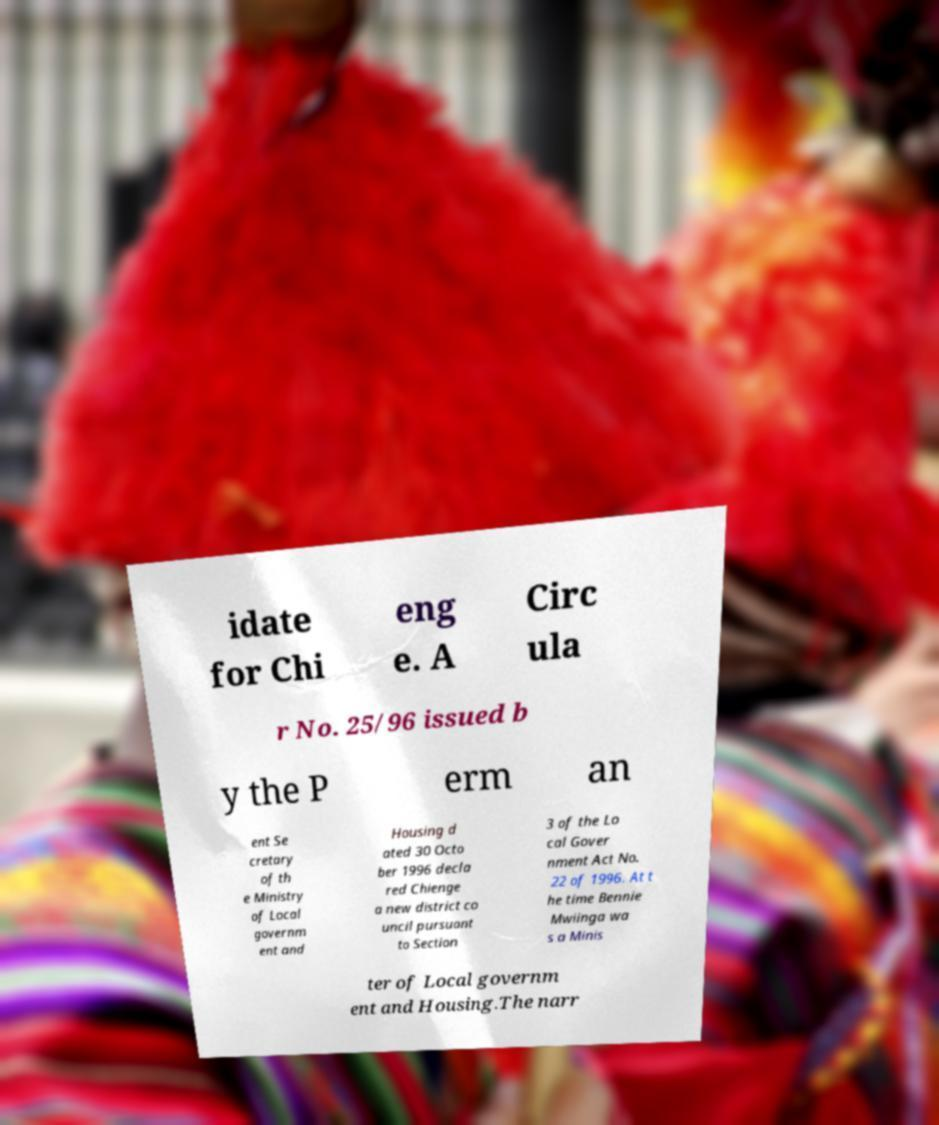Could you assist in decoding the text presented in this image and type it out clearly? idate for Chi eng e. A Circ ula r No. 25/96 issued b y the P erm an ent Se cretary of th e Ministry of Local governm ent and Housing d ated 30 Octo ber 1996 decla red Chienge a new district co uncil pursuant to Section 3 of the Lo cal Gover nment Act No. 22 of 1996. At t he time Bennie Mwiinga wa s a Minis ter of Local governm ent and Housing.The narr 